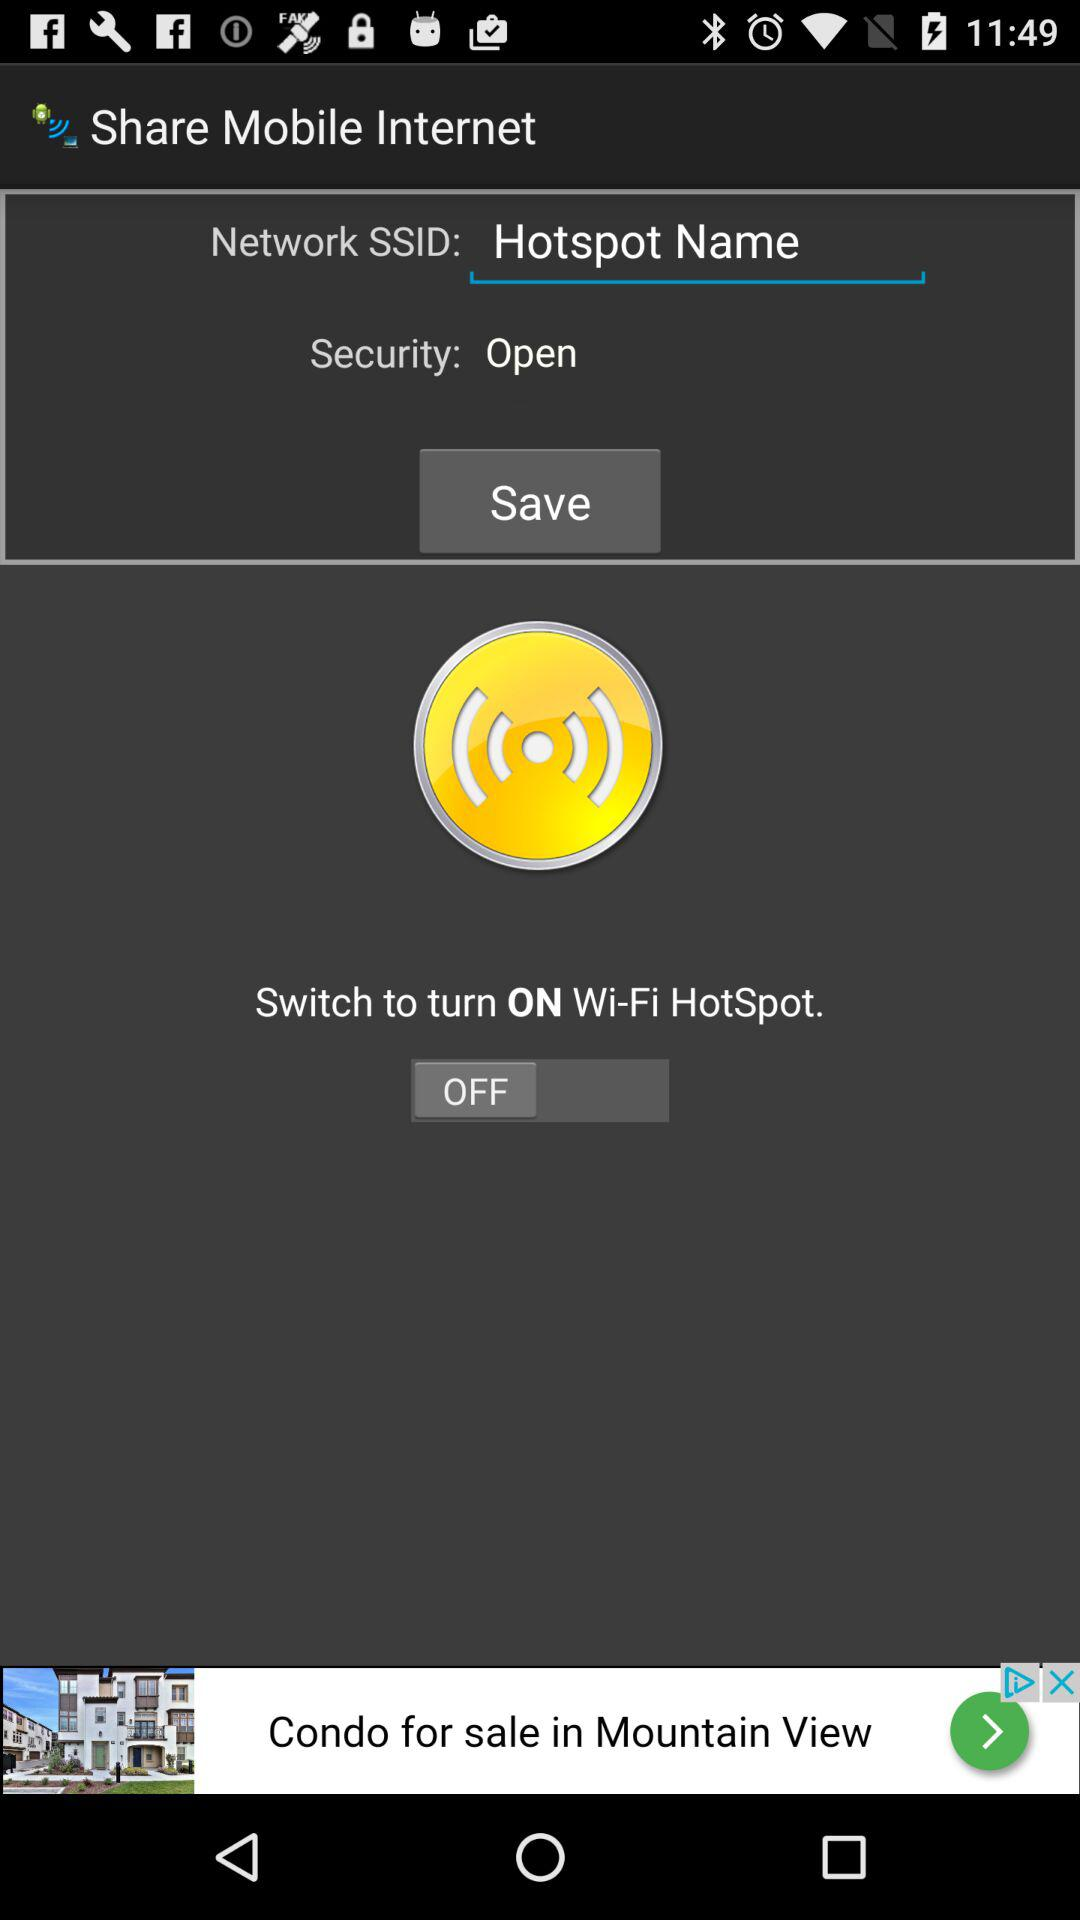What is the "Network SSID" shown there? The "Network SSID" shown there is "Hotspot Name". 